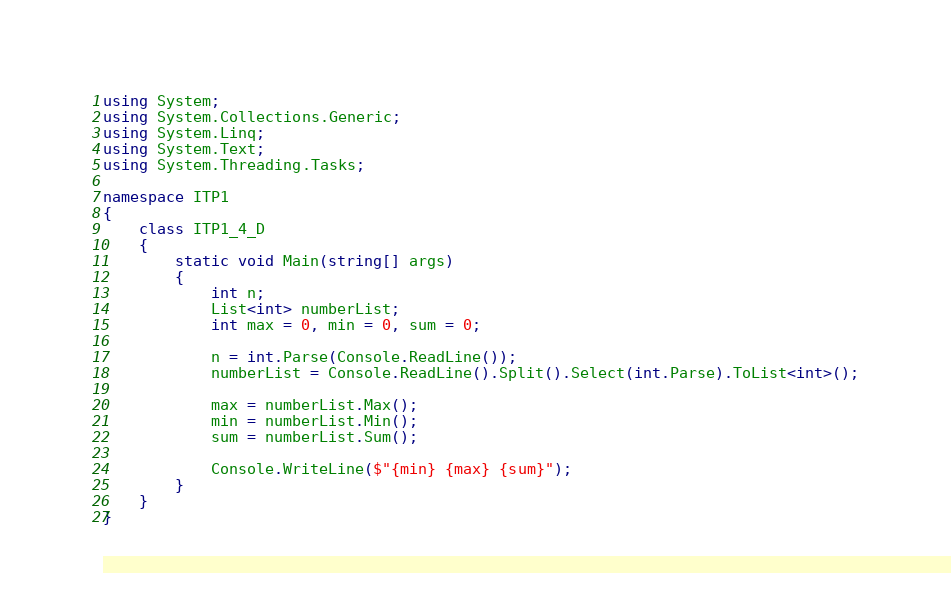Convert code to text. <code><loc_0><loc_0><loc_500><loc_500><_C#_>using System;
using System.Collections.Generic;
using System.Linq;
using System.Text;
using System.Threading.Tasks;

namespace ITP1
{
    class ITP1_4_D
    {
        static void Main(string[] args)
        {
            int n;
            List<int> numberList;
            int max = 0, min = 0, sum = 0;

            n = int.Parse(Console.ReadLine());
            numberList = Console.ReadLine().Split().Select(int.Parse).ToList<int>();

            max = numberList.Max();
            min = numberList.Min();
            sum = numberList.Sum();

            Console.WriteLine($"{min} {max} {sum}");
        }
    }
}

</code> 